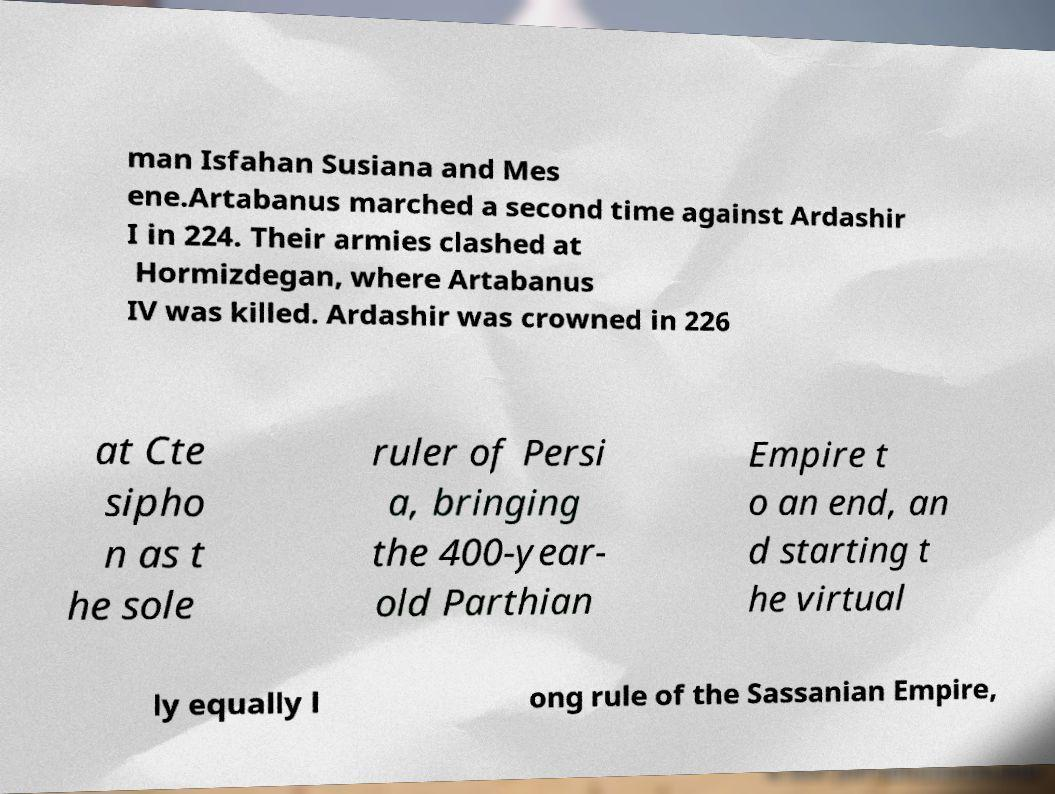Please identify and transcribe the text found in this image. man Isfahan Susiana and Mes ene.Artabanus marched a second time against Ardashir I in 224. Their armies clashed at Hormizdegan, where Artabanus IV was killed. Ardashir was crowned in 226 at Cte sipho n as t he sole ruler of Persi a, bringing the 400-year- old Parthian Empire t o an end, an d starting t he virtual ly equally l ong rule of the Sassanian Empire, 